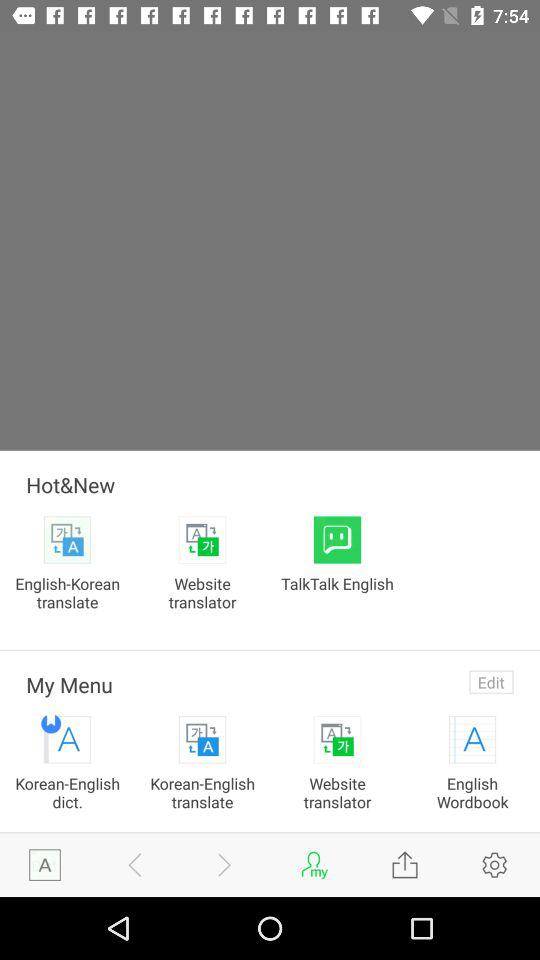Which application can be used to choose "Hot&New"? The applications that can be used to choose "Hot&New" are "English-Korean translate", "Website translator" and "TalkTalk English". 